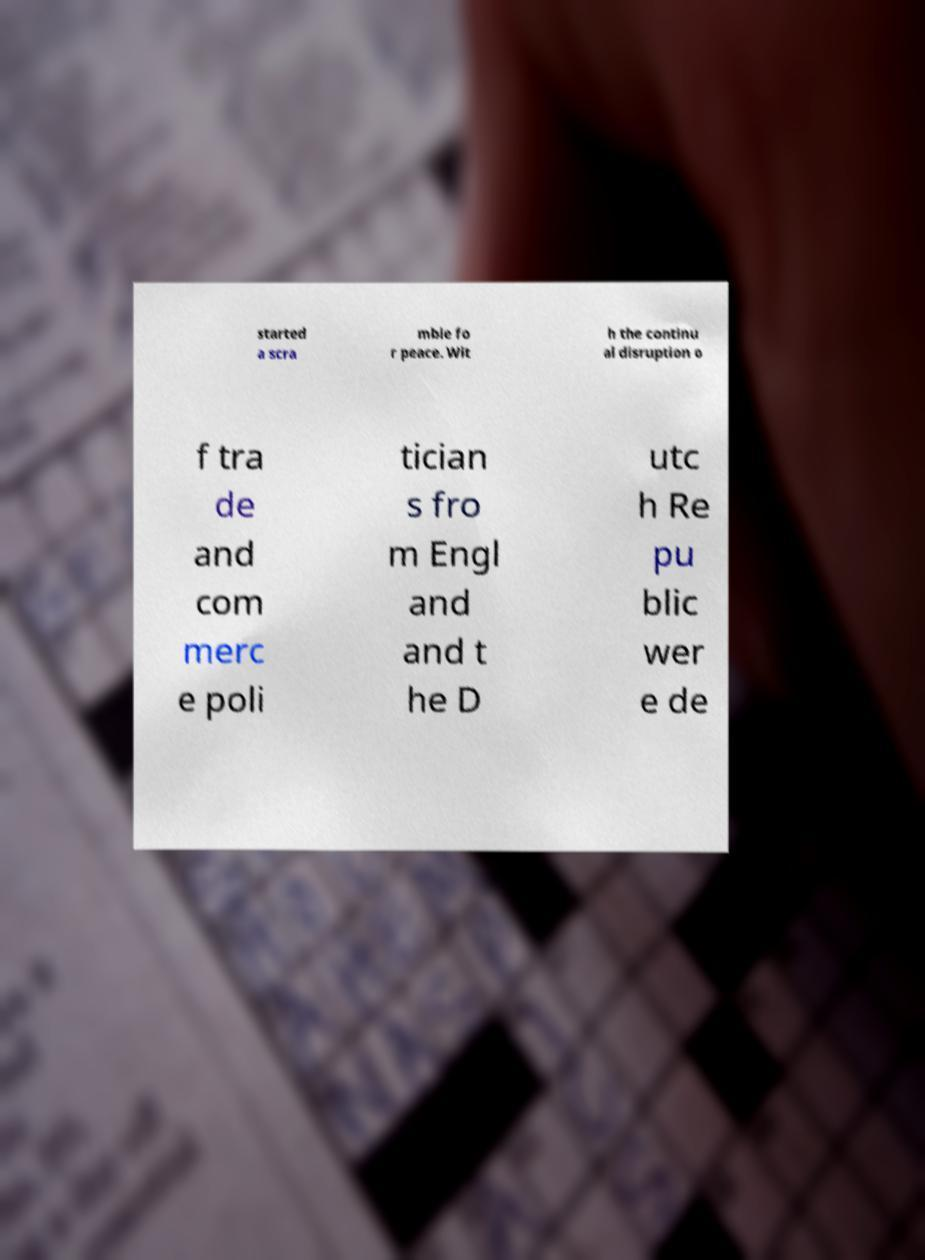Could you assist in decoding the text presented in this image and type it out clearly? started a scra mble fo r peace. Wit h the continu al disruption o f tra de and com merc e poli tician s fro m Engl and and t he D utc h Re pu blic wer e de 